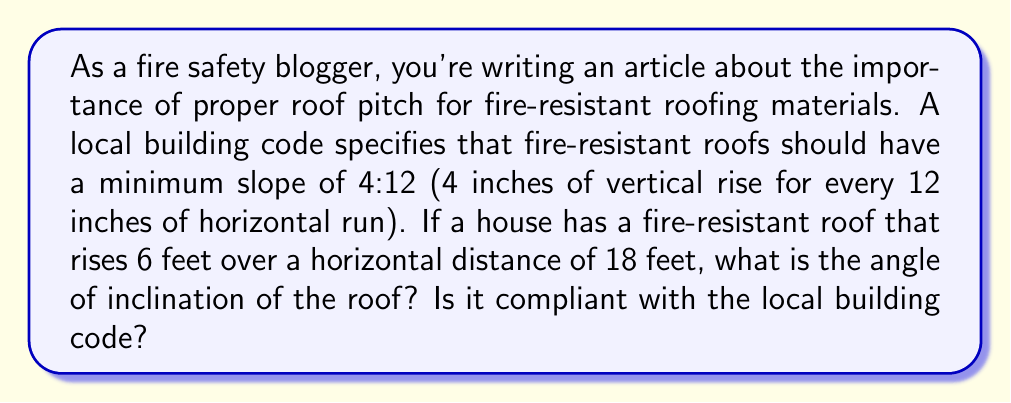Give your solution to this math problem. To solve this problem, we need to follow these steps:

1. Calculate the slope ratio of the given roof:
   The roof rises 6 feet over 18 feet horizontal distance.
   Slope ratio = $\frac{\text{Rise}}{\text{Run}} = \frac{6 \text{ feet}}{18 \text{ feet}} = \frac{1}{3}$

2. Convert the slope ratio to a comparable format with the building code (x:12):
   $\frac{1}{3} = \frac{x}{12}$
   $x = 12 \cdot \frac{1}{3} = 4$
   So, the slope is 4:12, which meets the minimum requirement.

3. Calculate the angle of inclination:
   We can use the arctangent function to find the angle.
   $\theta = \arctan(\frac{\text{Rise}}{\text{Run}})$

   [asy]
   import geometry;
   
   size(200);
   
   pair A = (0,0), B = (18,0), C = (18,6);
   draw(A--B--C--A);
   
   label("18 ft", (9,0), S);
   label("6 ft", (18,3), E);
   label("$\theta$", (1,0.5), NW);
   
   draw(A--(1,0), arrow=Arrow(TeXHead));
   draw((1,0)--(1,0.5), arrow=Arrow(TeXHead));
   [/asy]

   $\theta = \arctan(\frac{6}{18}) = \arctan(\frac{1}{3})$

4. Convert the result to degrees:
   $\theta = \arctan(\frac{1}{3}) \approx 0.3217 \text{ radians}$
   $\theta \approx 0.3217 \cdot \frac{180^{\circ}}{\pi} \approx 18.43^{\circ}$

Therefore, the angle of inclination of the roof is approximately 18.43°, and it is compliant with the local building code as it meets the minimum 4:12 slope requirement.
Answer: The angle of inclination of the roof is approximately $18.43^{\circ}$, and it is compliant with the local building code. 